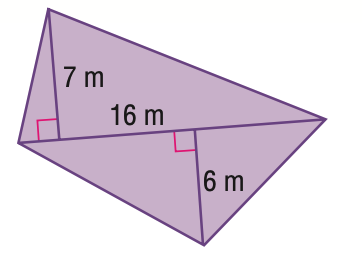Question: Find the area of the quadrilateral.
Choices:
A. 96
B. 104
C. 112
D. 208
Answer with the letter. Answer: B 